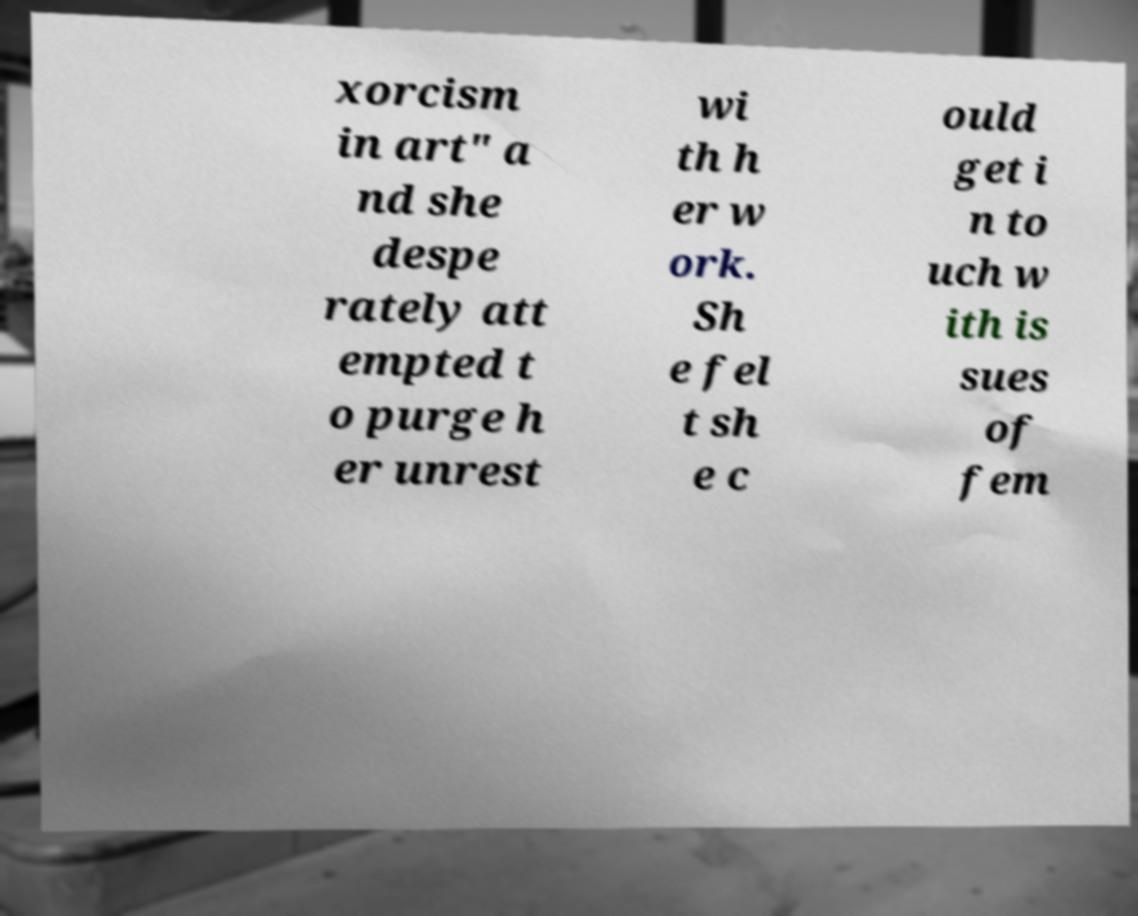I need the written content from this picture converted into text. Can you do that? xorcism in art" a nd she despe rately att empted t o purge h er unrest wi th h er w ork. Sh e fel t sh e c ould get i n to uch w ith is sues of fem 